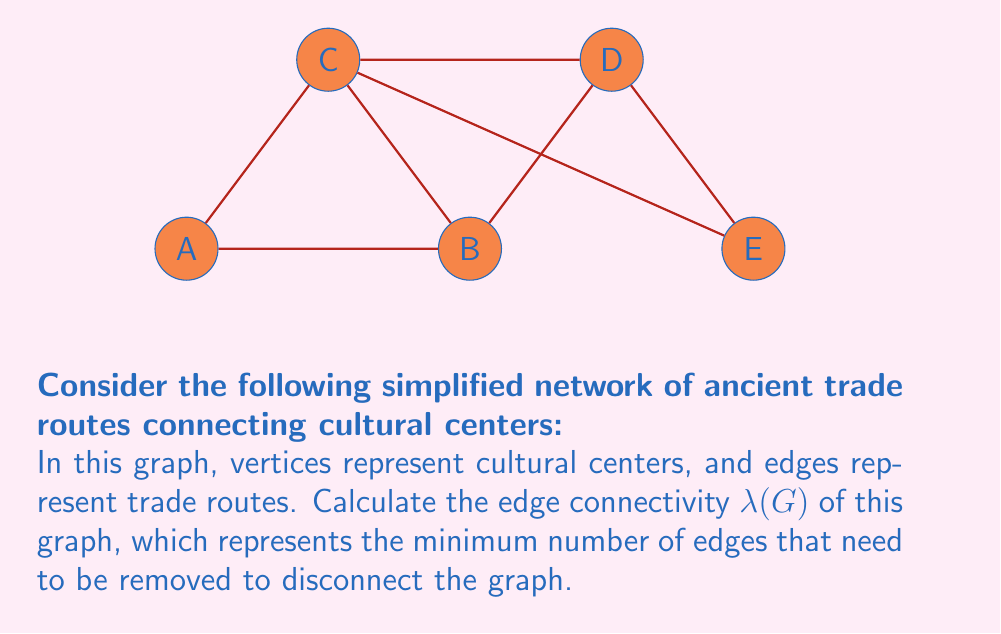Teach me how to tackle this problem. To find the edge connectivity $\lambda(G)$ of this graph, we need to determine the minimum number of edges that, when removed, will disconnect the graph. Let's approach this step-by-step:

1) First, observe that the graph is connected, as there is a path between any two vertices.

2) To disconnect the graph, we need to find the smallest set of edges that, when removed, will separate at least one vertex from the rest.

3) Let's consider each vertex:
   - Vertex A: Connected by 2 edges (A-B and A-C)
   - Vertex B: Connected by 3 edges (B-A, B-C, B-D)
   - Vertex C: Connected by 4 edges (C-A, C-B, C-D, C-E)
   - Vertex D: Connected by 3 edges (D-B, D-C, D-E)
   - Vertex E: Connected by 2 edges (E-C and E-D)

4) The vertices with the fewest connections are A and E, each with 2 edges.

5) Removing both edges connected to either A or E would disconnect that vertex from the rest of the graph.

6) Therefore, the minimum number of edges that need to be removed to disconnect the graph is 2.

Thus, the edge connectivity $\lambda(G) = 2$.

Note: In graph theory, the edge connectivity is always less than or equal to the minimum degree of the graph. Here, the minimum degree is 2 (for vertices A and E), which confirms our result.
Answer: $\lambda(G) = 2$ 